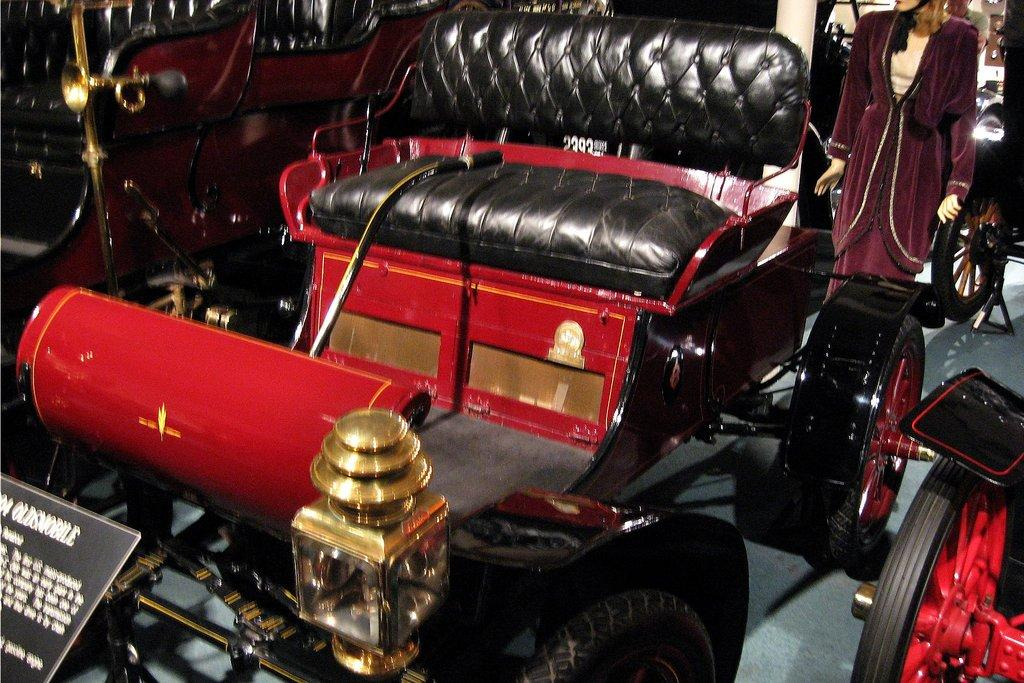What types of objects are present in the image? There are vehicles, a mannequin with clothes, and a board with text in the image. Can you describe the vehicles in the image? Unfortunately, the facts provided do not give specific details about the vehicles. What is the mannequin wearing in the image? The facts provided do not specify the type of clothes the mannequin is wearing. What does the text on the board say in the image? The facts provided do not give the specific text on the board. Can you see any lettuce floating in the ocean in the image? There is no mention of an ocean or lettuce in the provided facts, so we cannot answer this question based on the image. 